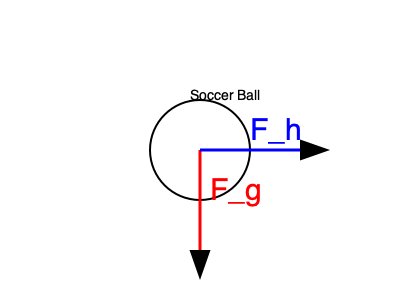A soccer player heads a ball with a force of 100 N at an angle of 30° above the horizontal. If the mass of the ball is 0.45 kg, what is the initial acceleration of the ball immediately after impact? Assume gravity acts downward with $g = 9.8 \frac{m}{s^2}$. Use the force diagram provided. To solve this problem, we'll follow these steps:

1) Identify the forces acting on the ball:
   - $F_h$: Heading force (100 N at 30° above horizontal)
   - $F_g$: Gravitational force (mass * g)

2) Break down the heading force into horizontal and vertical components:
   $F_{hx} = F_h \cos(30°) = 100 \cdot \cos(30°) = 86.6$ N
   $F_{hy} = F_h \sin(30°) = 100 \cdot \sin(30°) = 50$ N

3) Calculate the gravitational force:
   $F_g = mg = 0.45 \cdot 9.8 = 4.41$ N

4) Find the net force in each direction:
   $F_{net,x} = F_{hx} = 86.6$ N
   $F_{net,y} = F_{hy} - F_g = 50 - 4.41 = 45.59$ N

5) Use Newton's Second Law ($F = ma$) to find acceleration components:
   $a_x = \frac{F_{net,x}}{m} = \frac{86.6}{0.45} = 192.4 \frac{m}{s^2}$
   $a_y = \frac{F_{net,y}}{m} = \frac{45.59}{0.45} = 101.3 \frac{m}{s^2}$

6) Calculate the magnitude of the total acceleration using the Pythagorean theorem:
   $a = \sqrt{a_x^2 + a_y^2} = \sqrt{192.4^2 + 101.3^2} = 217.3 \frac{m}{s^2}$
Answer: $217.3 \frac{m}{s^2}$ 